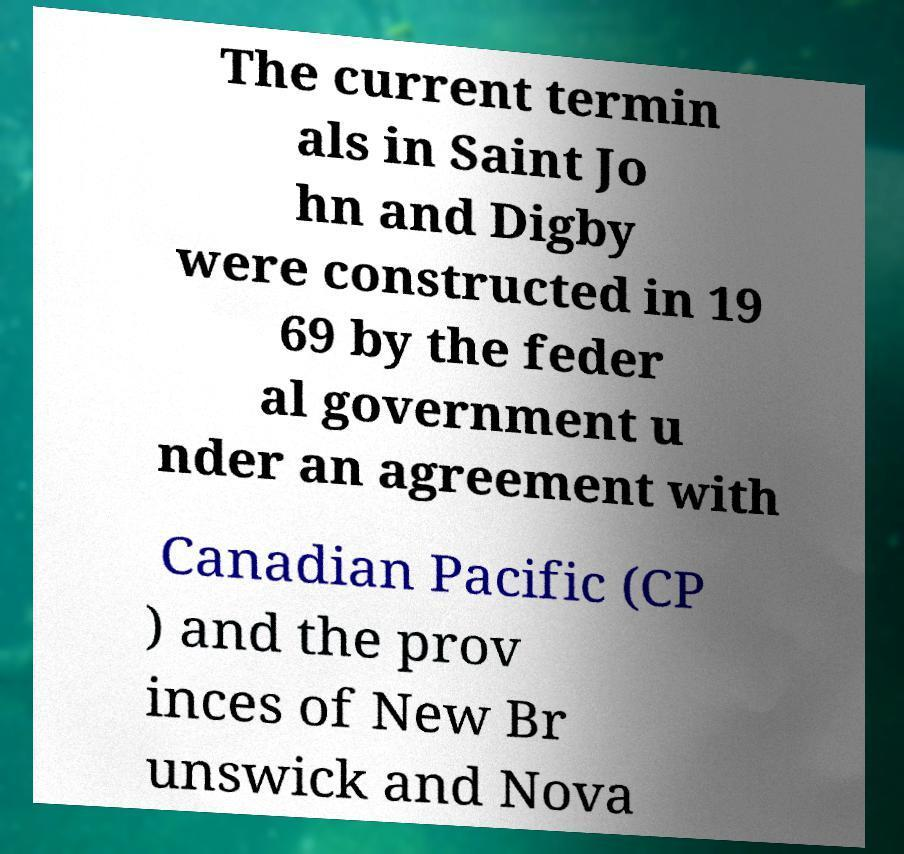What messages or text are displayed in this image? I need them in a readable, typed format. The current termin als in Saint Jo hn and Digby were constructed in 19 69 by the feder al government u nder an agreement with Canadian Pacific (CP ) and the prov inces of New Br unswick and Nova 